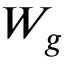<formula> <loc_0><loc_0><loc_500><loc_500>W _ { g }</formula> 